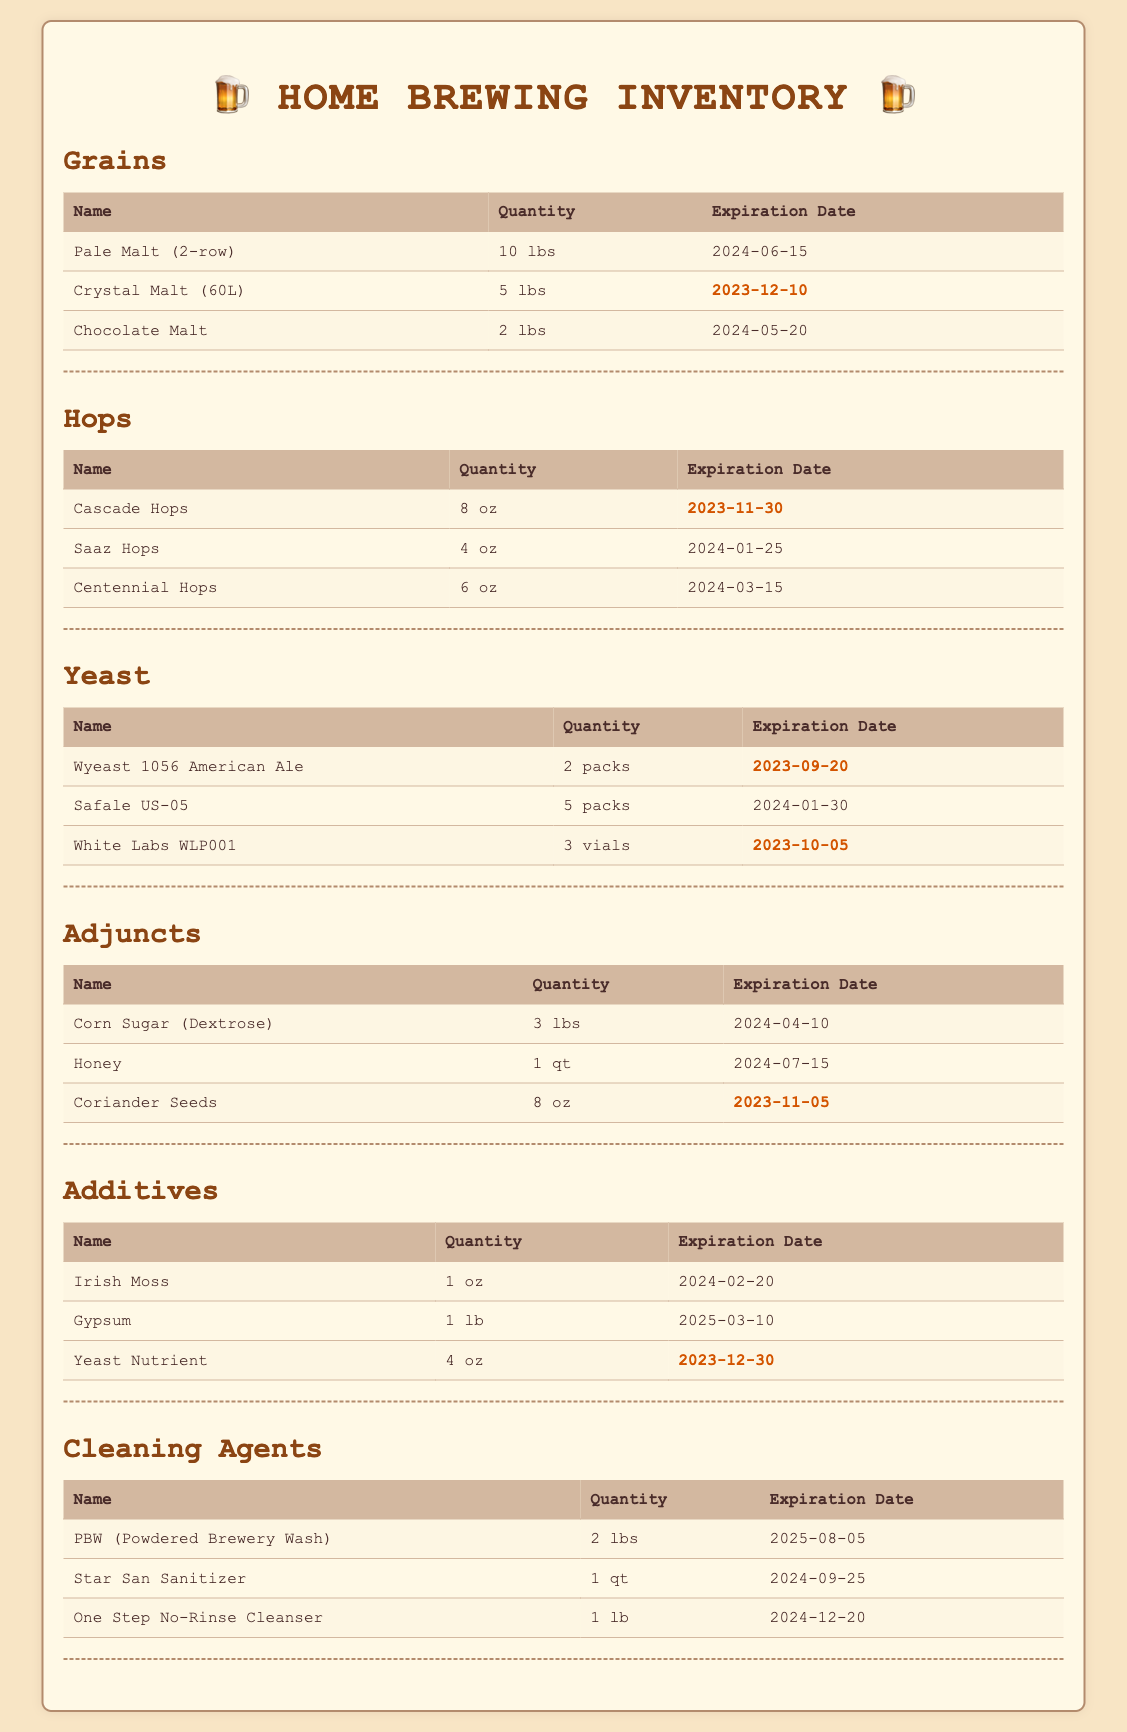What is the expiration date of Crystal Malt (60L)? The expiration date for Crystal Malt (60L) is specifically listed in the grains category of the inventory.
Answer: 2023-12-10 How many packs of Safale US-05 yeast are available? The available quantity of Safale US-05 yeast can be found in the yeast category of the document.
Answer: 5 packs Which hops will expire the soonest? Identifying the hops with the nearest expiration date requires comparing the expiration dates of all hops listed.
Answer: Cascade Hops What is the quantity of Corn Sugar (Dextrose)? The quantity of Corn Sugar (Dextrose) is explicitly stated in the adjuncts section of the inventory.
Answer: 3 lbs How many total grains are listed in the inventory? The total number of grains can be found by counting the entries in the grains category of the document.
Answer: 3 Which cleaning agent has the latest expiration date? Determining which cleaning agent has the latest expiration date involves comparing the expiration dates listed under the cleaning agents category.
Answer: PBW (Powdered Brewery Wash) What is the total quantity of hops listed? The total quantity involves summing the quantities from all listed hops in the hops category.
Answer: 18 oz When does the yeast nutrient expire? The expiration date for the yeast nutrient is specifically provided in the additives category.
Answer: 2023-12-30 How many ounces of coriander seeds are available? The quantity of coriander seeds is clearly mentioned in the adjuncts section of the inventory.
Answer: 8 oz 